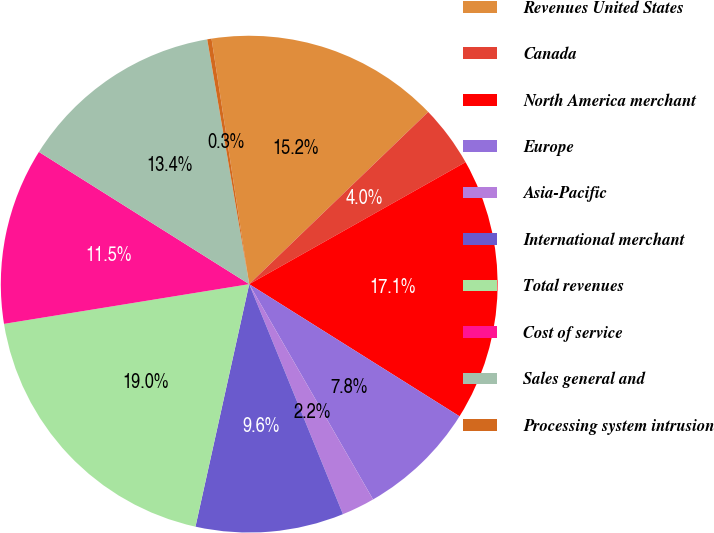<chart> <loc_0><loc_0><loc_500><loc_500><pie_chart><fcel>Revenues United States<fcel>Canada<fcel>North America merchant<fcel>Europe<fcel>Asia-Pacific<fcel>International merchant<fcel>Total revenues<fcel>Cost of service<fcel>Sales general and<fcel>Processing system intrusion<nl><fcel>15.23%<fcel>4.02%<fcel>17.1%<fcel>7.76%<fcel>2.15%<fcel>9.63%<fcel>18.97%<fcel>11.49%<fcel>13.36%<fcel>0.28%<nl></chart> 